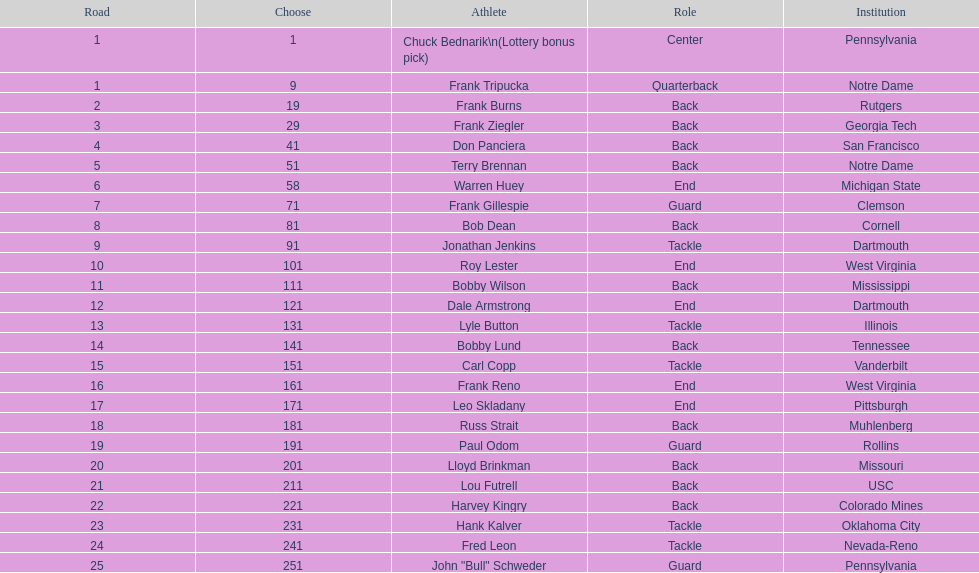Who was picked after roy lester? Bobby Wilson. 